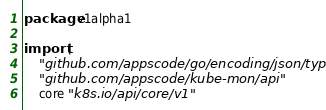<code> <loc_0><loc_0><loc_500><loc_500><_Go_>package v1alpha1

import (
	"github.com/appscode/go/encoding/json/types"
	"github.com/appscode/kube-mon/api"
	core "k8s.io/api/core/v1"</code> 